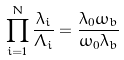Convert formula to latex. <formula><loc_0><loc_0><loc_500><loc_500>\prod _ { i = 1 } ^ { N } \frac { \lambda _ { i } } { \Lambda _ { i } } = \frac { \lambda _ { 0 } \omega _ { b } } { \omega _ { 0 } \lambda _ { b } }</formula> 